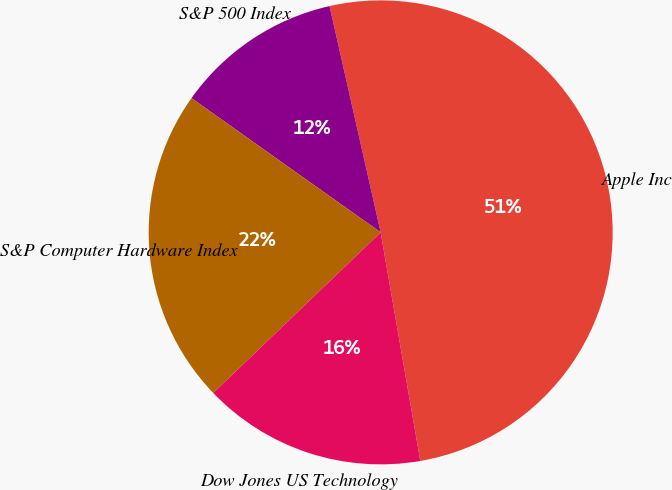<chart> <loc_0><loc_0><loc_500><loc_500><pie_chart><fcel>Apple Inc<fcel>S&P 500 Index<fcel>S&P Computer Hardware Index<fcel>Dow Jones US Technology<nl><fcel>50.8%<fcel>11.64%<fcel>21.99%<fcel>15.56%<nl></chart> 